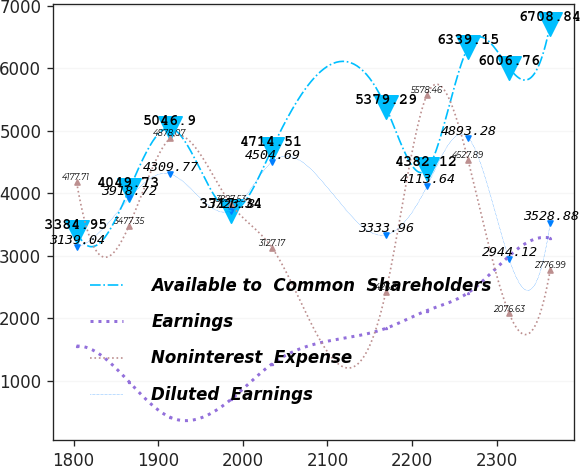<chart> <loc_0><loc_0><loc_500><loc_500><line_chart><ecel><fcel>Available to  Common  Shareholders<fcel>Earnings<fcel>Noninterest  Expense<fcel>Diluted  Earnings<nl><fcel>1803.49<fcel>3384.95<fcel>1554.75<fcel>4177.71<fcel>3139.04<nl><fcel>1865.32<fcel>4049.73<fcel>985.45<fcel>3477.35<fcel>3918.72<nl><fcel>1913.89<fcel>5046.9<fcel>416.15<fcel>4878.07<fcel>4309.77<nl><fcel>1985.93<fcel>3717.34<fcel>700.8<fcel>3827.53<fcel>3723.8<nl><fcel>2034.5<fcel>4714.51<fcel>1270.1<fcel>3127.17<fcel>4504.69<nl><fcel>2169.14<fcel>5379.29<fcel>1839.4<fcel>2426.81<fcel>3333.96<nl><fcel>2217.71<fcel>4382.12<fcel>2124.05<fcel>5578.46<fcel>4113.64<nl><fcel>2266.28<fcel>6339.15<fcel>2408.7<fcel>4527.89<fcel>4893.28<nl><fcel>2314.85<fcel>6006.76<fcel>2998.34<fcel>2076.63<fcel>2944.12<nl><fcel>2363.42<fcel>6708.84<fcel>3282.99<fcel>2776.99<fcel>3528.88<nl></chart> 